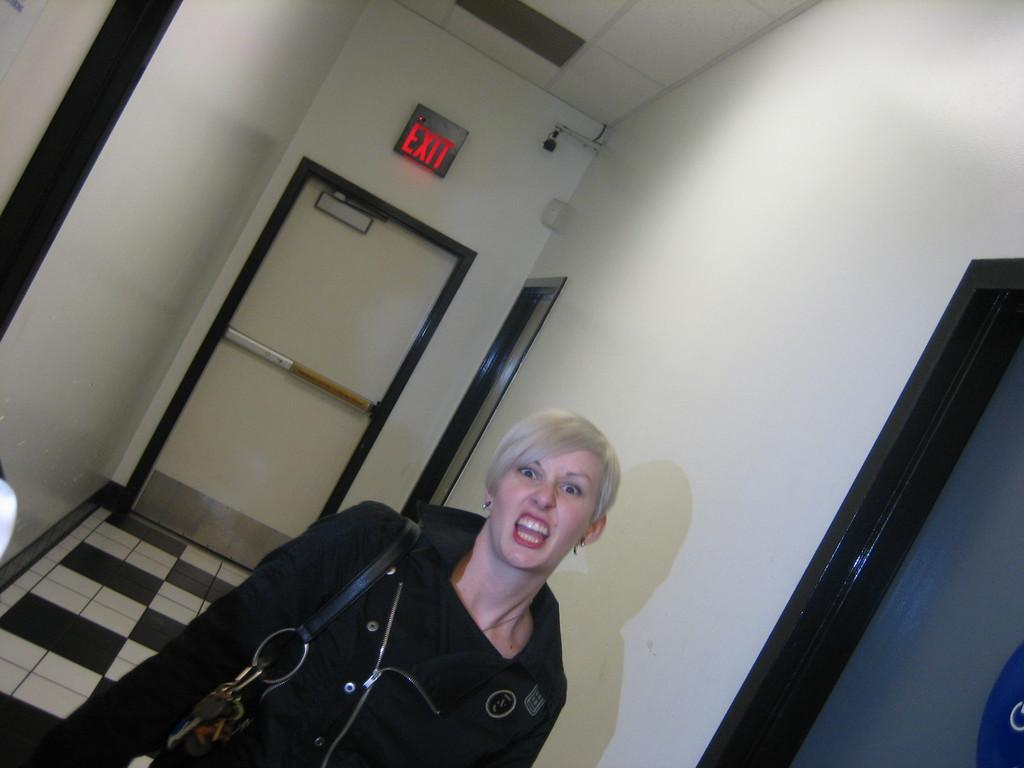What is the main subject of the image? There is a person in the image. Can you describe anything in the background of the image? There is text written on a wall in the background of the image. What type of goat can be seen attacking the person in the image? There is no goat present in the image, nor is there any indication of an attack. 